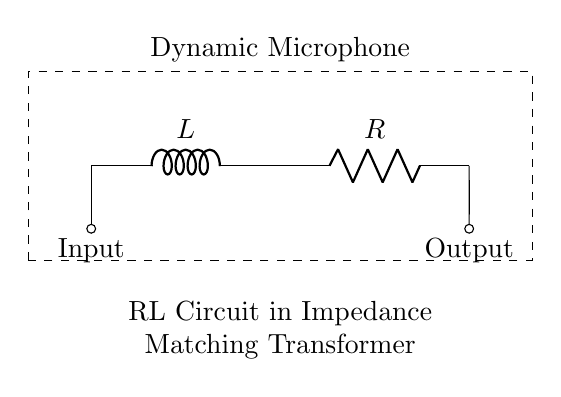What components are in the circuit? The circuit includes a resistor and an inductor, indicated by the labels R and L, respectively.
Answer: Resistor and Inductor What does the input node represent? The input node, marked as "Input," represents where an electrical signal enters the microphone circuit.
Answer: Input What is the function of the RL circuit in this diagram? The RL circuit functions to match the impedance of the dynamic microphone to that of the following audio equipment, helping to optimize signal transfer.
Answer: Impedance matching Describe the overall purpose of the dynamic microphone depicted. The dynamic microphone converts sound waves into electrical signals and the RL circuit ensures efficient transmission of these signals.
Answer: Sound to electrical signal conversion What is the role of the resistor in this RL circuit? The resistor, labeled R, helps control the current flow in the circuit, influencing the voltage drop across components and stabilizing the circuit.
Answer: Current control How does the inductor affect the circuit behavior? The inductor stores energy in a magnetic field and introduces impedance that varies with frequency, affecting the circuit's response to different audio signals.
Answer: Impedance variation with frequency What type of circuit is shown in this diagram? The circuit is an RL circuit, specifically designed for use in audio applications like microphones to manage impedance.
Answer: RL circuit 